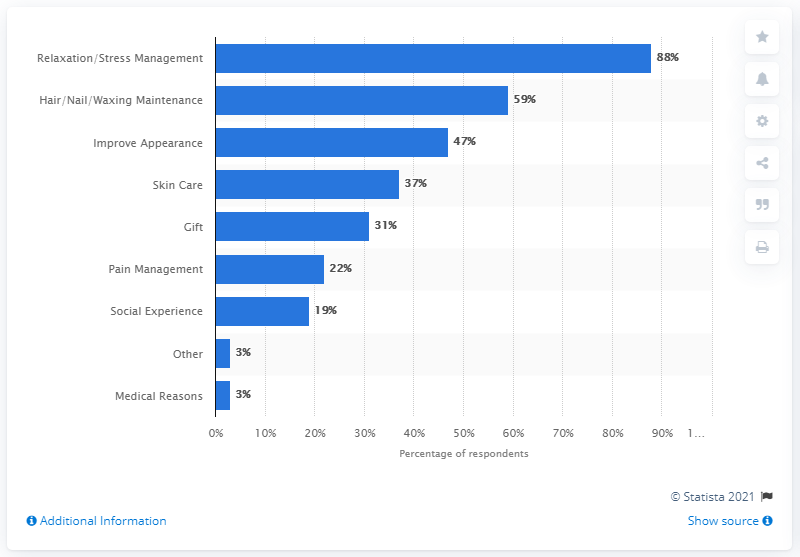Give some essential details in this illustration. In 2011, 37% of interviewees reported that skin care was a reason for visiting a spa. 